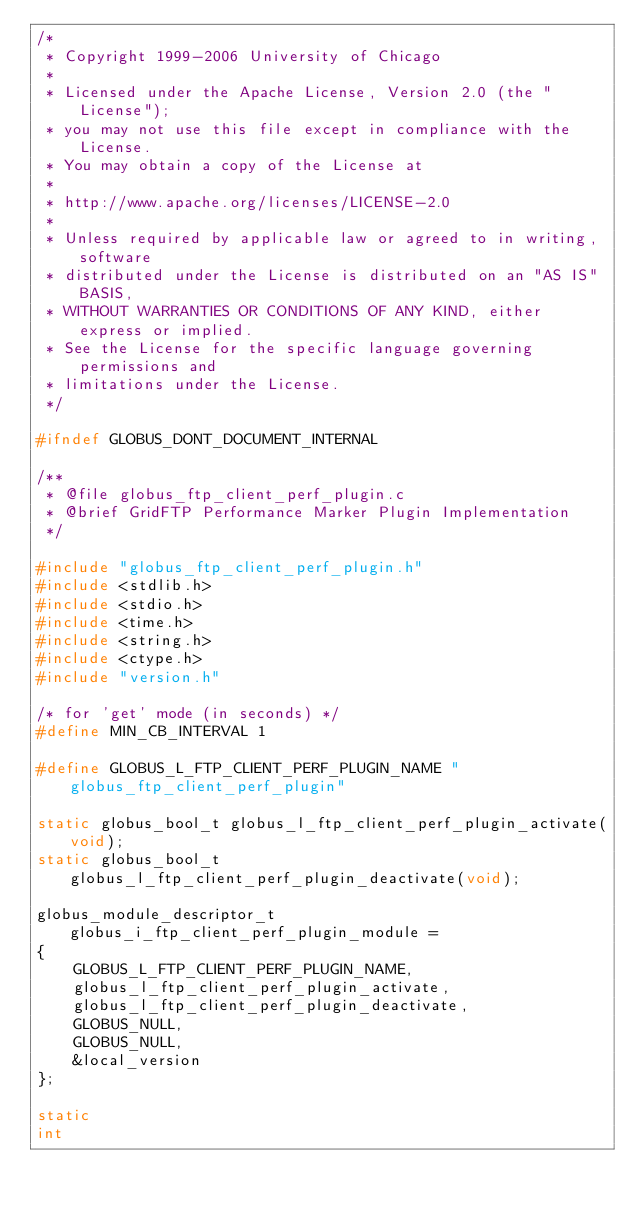Convert code to text. <code><loc_0><loc_0><loc_500><loc_500><_C_>/*
 * Copyright 1999-2006 University of Chicago
 * 
 * Licensed under the Apache License, Version 2.0 (the "License");
 * you may not use this file except in compliance with the License.
 * You may obtain a copy of the License at
 * 
 * http://www.apache.org/licenses/LICENSE-2.0
 * 
 * Unless required by applicable law or agreed to in writing, software
 * distributed under the License is distributed on an "AS IS" BASIS,
 * WITHOUT WARRANTIES OR CONDITIONS OF ANY KIND, either express or implied.
 * See the License for the specific language governing permissions and
 * limitations under the License.
 */

#ifndef GLOBUS_DONT_DOCUMENT_INTERNAL

/**
 * @file globus_ftp_client_perf_plugin.c
 * @brief GridFTP Performance Marker Plugin Implementation
 */

#include "globus_ftp_client_perf_plugin.h"
#include <stdlib.h>
#include <stdio.h>
#include <time.h>
#include <string.h>
#include <ctype.h>
#include "version.h"

/* for 'get' mode (in seconds) */
#define MIN_CB_INTERVAL 1

#define GLOBUS_L_FTP_CLIENT_PERF_PLUGIN_NAME "globus_ftp_client_perf_plugin"

static globus_bool_t globus_l_ftp_client_perf_plugin_activate(void);
static globus_bool_t globus_l_ftp_client_perf_plugin_deactivate(void);

globus_module_descriptor_t globus_i_ftp_client_perf_plugin_module =
{
    GLOBUS_L_FTP_CLIENT_PERF_PLUGIN_NAME,
    globus_l_ftp_client_perf_plugin_activate,
    globus_l_ftp_client_perf_plugin_deactivate,
    GLOBUS_NULL,
    GLOBUS_NULL,
    &local_version
};

static
int</code> 